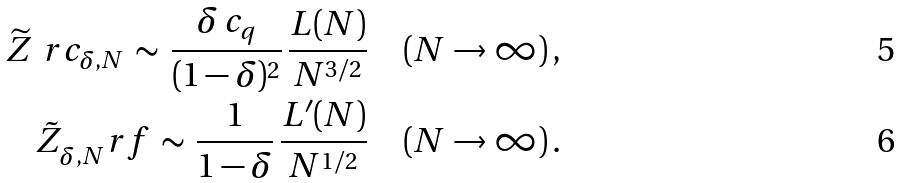<formula> <loc_0><loc_0><loc_500><loc_500>\widetilde { Z } ^ { \ } r c _ { \delta , N } \, \sim \, \frac { \delta \, c _ { q } } { ( 1 - \delta ) ^ { 2 } } \, \frac { L ( N ) } { N ^ { 3 / 2 } } \quad ( N \to \infty ) \, , \\ \tilde { Z } _ { \delta , N } ^ { \ } r f \, \sim \, \frac { 1 } { 1 - \delta } \, \frac { L ^ { \prime } ( N ) } { N ^ { 1 / 2 } } \quad ( N \to \infty ) \, .</formula> 